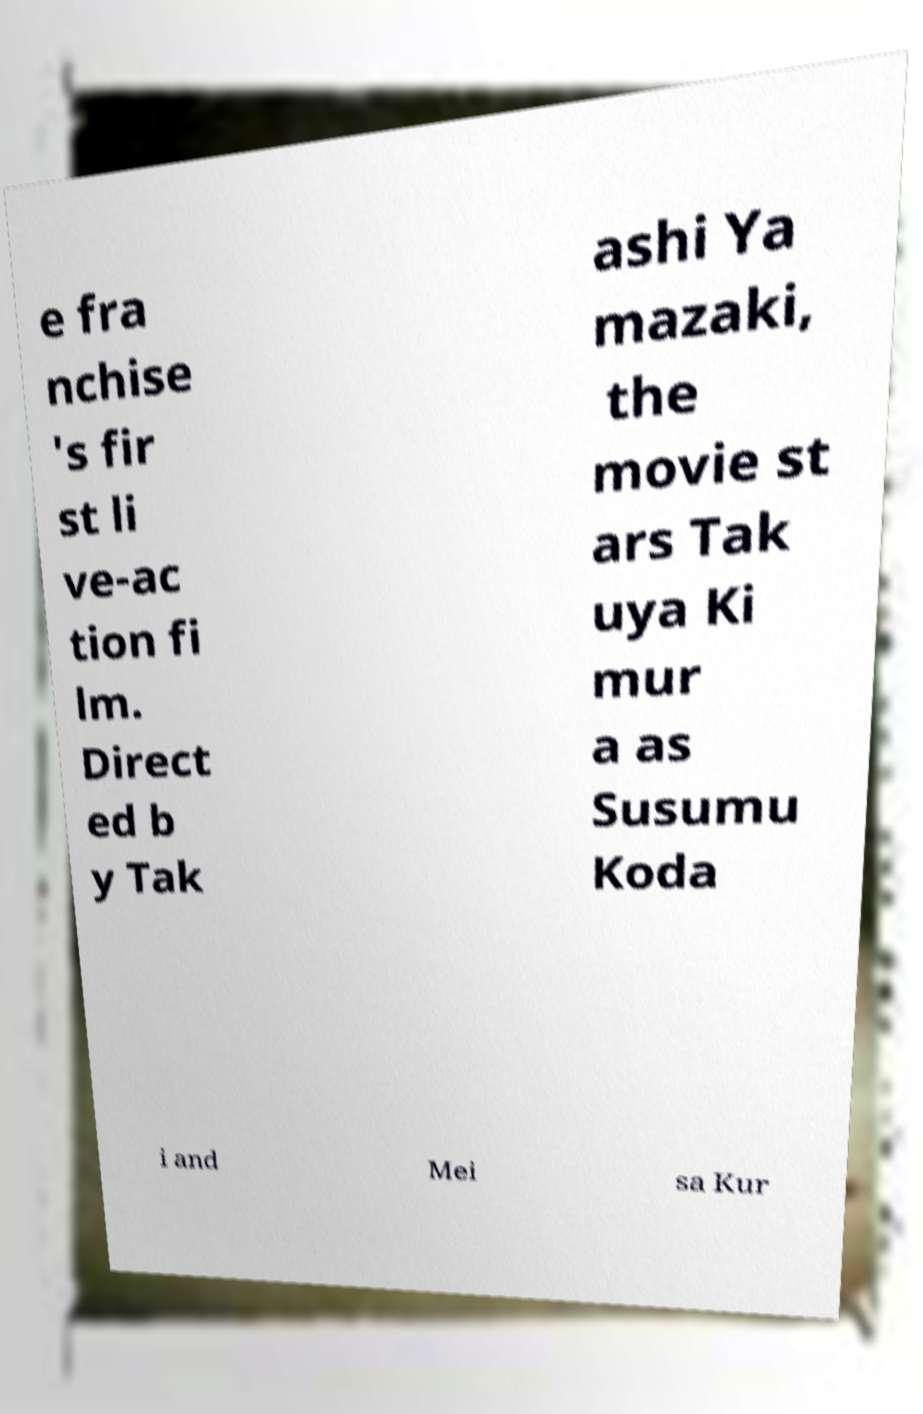Can you read and provide the text displayed in the image?This photo seems to have some interesting text. Can you extract and type it out for me? e fra nchise 's fir st li ve-ac tion fi lm. Direct ed b y Tak ashi Ya mazaki, the movie st ars Tak uya Ki mur a as Susumu Koda i and Mei sa Kur 